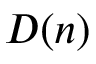Convert formula to latex. <formula><loc_0><loc_0><loc_500><loc_500>D ( n )</formula> 